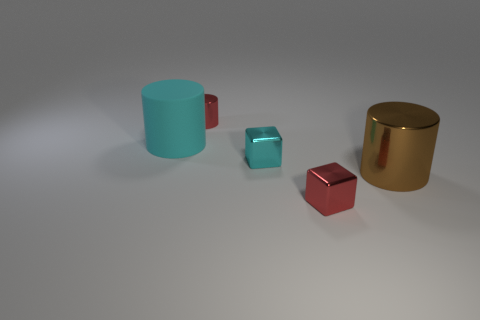There is another small thing that is the same shape as the cyan shiny object; what material is it? The small object that shares the same cubic shape as the cyan shiny object appears to be made of a similar reflective material, likely metal as well, given its reflective surface and similarity in appearance to the other object. 